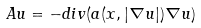Convert formula to latex. <formula><loc_0><loc_0><loc_500><loc_500>A u = - d i v ( a ( x , | \nabla u | ) \nabla u )</formula> 